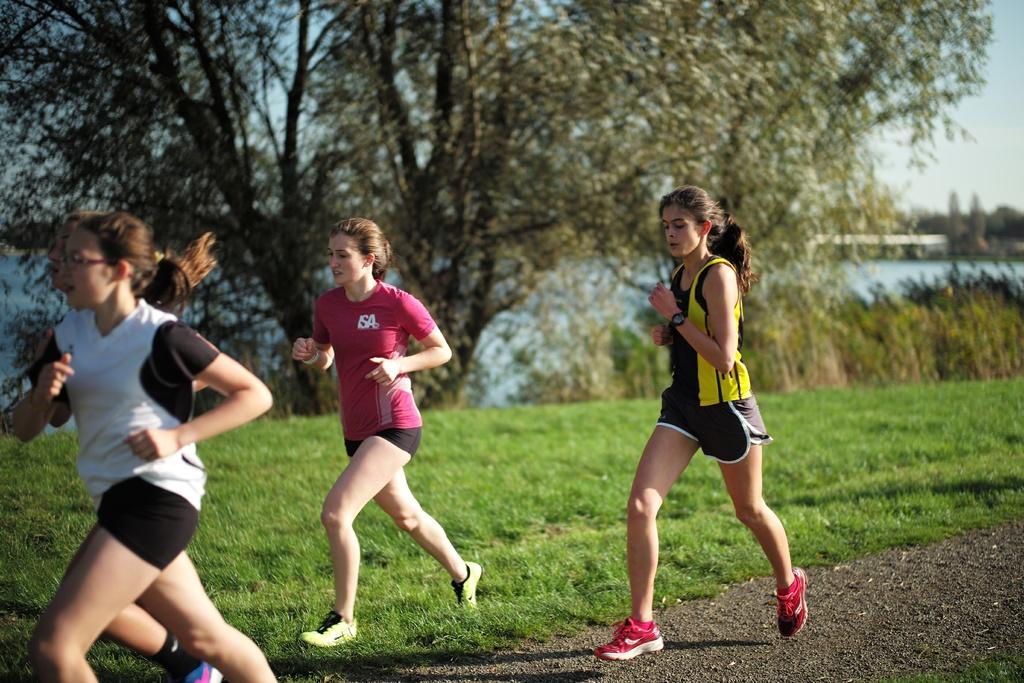What are the four women in the image doing? The four women in the image are running. What type of terrain can be seen in the image? There is grass in the image, which suggests a natural, outdoor setting. What other types of vegetation are present in the image? There are plants and trees in the image. What can be seen in the background of the image? Water and the sky are visible in the background of the image. How many dogs are pulling the wheel in the image? There are no dogs or wheels present in the image. What type of screw is being used to secure the plants in the image? There are no screws visible in the image; the plants are secured by their roots in the soil. 